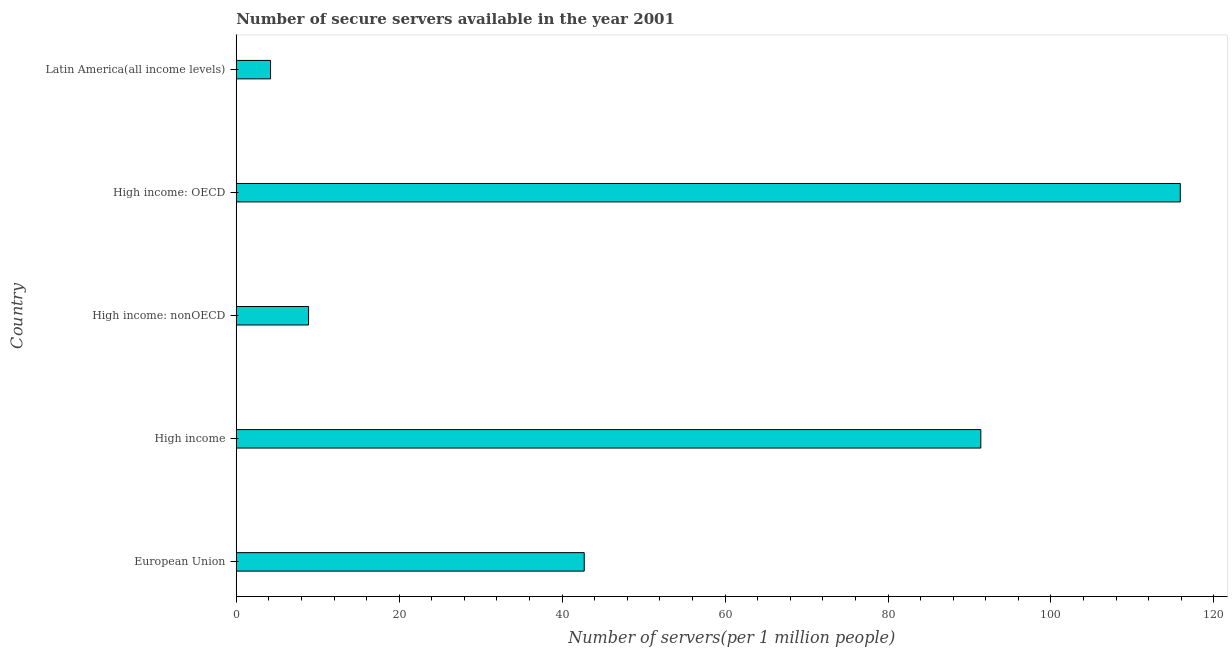What is the title of the graph?
Your answer should be very brief. Number of secure servers available in the year 2001. What is the label or title of the X-axis?
Provide a short and direct response. Number of servers(per 1 million people). What is the number of secure internet servers in High income: nonOECD?
Offer a very short reply. 8.88. Across all countries, what is the maximum number of secure internet servers?
Provide a short and direct response. 115.88. Across all countries, what is the minimum number of secure internet servers?
Offer a very short reply. 4.21. In which country was the number of secure internet servers maximum?
Ensure brevity in your answer.  High income: OECD. In which country was the number of secure internet servers minimum?
Your response must be concise. Latin America(all income levels). What is the sum of the number of secure internet servers?
Offer a terse response. 263.07. What is the difference between the number of secure internet servers in High income and High income: nonOECD?
Offer a very short reply. 82.52. What is the average number of secure internet servers per country?
Offer a terse response. 52.61. What is the median number of secure internet servers?
Your response must be concise. 42.71. In how many countries, is the number of secure internet servers greater than 92 ?
Offer a terse response. 1. What is the ratio of the number of secure internet servers in High income to that in High income: OECD?
Your answer should be very brief. 0.79. Is the number of secure internet servers in European Union less than that in Latin America(all income levels)?
Provide a succinct answer. No. What is the difference between the highest and the second highest number of secure internet servers?
Your answer should be very brief. 24.49. Is the sum of the number of secure internet servers in High income and Latin America(all income levels) greater than the maximum number of secure internet servers across all countries?
Keep it short and to the point. No. What is the difference between the highest and the lowest number of secure internet servers?
Make the answer very short. 111.67. How many bars are there?
Your answer should be compact. 5. Are all the bars in the graph horizontal?
Your response must be concise. Yes. How many countries are there in the graph?
Your answer should be compact. 5. What is the difference between two consecutive major ticks on the X-axis?
Provide a succinct answer. 20. Are the values on the major ticks of X-axis written in scientific E-notation?
Your answer should be compact. No. What is the Number of servers(per 1 million people) of European Union?
Your answer should be very brief. 42.71. What is the Number of servers(per 1 million people) of High income?
Offer a very short reply. 91.39. What is the Number of servers(per 1 million people) in High income: nonOECD?
Provide a short and direct response. 8.88. What is the Number of servers(per 1 million people) in High income: OECD?
Your response must be concise. 115.88. What is the Number of servers(per 1 million people) in Latin America(all income levels)?
Your answer should be very brief. 4.21. What is the difference between the Number of servers(per 1 million people) in European Union and High income?
Offer a terse response. -48.68. What is the difference between the Number of servers(per 1 million people) in European Union and High income: nonOECD?
Provide a succinct answer. 33.84. What is the difference between the Number of servers(per 1 million people) in European Union and High income: OECD?
Ensure brevity in your answer.  -73.16. What is the difference between the Number of servers(per 1 million people) in European Union and Latin America(all income levels)?
Your answer should be compact. 38.51. What is the difference between the Number of servers(per 1 million people) in High income and High income: nonOECD?
Provide a succinct answer. 82.52. What is the difference between the Number of servers(per 1 million people) in High income and High income: OECD?
Your response must be concise. -24.49. What is the difference between the Number of servers(per 1 million people) in High income and Latin America(all income levels)?
Keep it short and to the point. 87.18. What is the difference between the Number of servers(per 1 million people) in High income: nonOECD and High income: OECD?
Offer a terse response. -107. What is the difference between the Number of servers(per 1 million people) in High income: nonOECD and Latin America(all income levels)?
Give a very brief answer. 4.67. What is the difference between the Number of servers(per 1 million people) in High income: OECD and Latin America(all income levels)?
Keep it short and to the point. 111.67. What is the ratio of the Number of servers(per 1 million people) in European Union to that in High income?
Keep it short and to the point. 0.47. What is the ratio of the Number of servers(per 1 million people) in European Union to that in High income: nonOECD?
Your response must be concise. 4.81. What is the ratio of the Number of servers(per 1 million people) in European Union to that in High income: OECD?
Your response must be concise. 0.37. What is the ratio of the Number of servers(per 1 million people) in European Union to that in Latin America(all income levels)?
Your response must be concise. 10.15. What is the ratio of the Number of servers(per 1 million people) in High income to that in High income: nonOECD?
Offer a terse response. 10.3. What is the ratio of the Number of servers(per 1 million people) in High income to that in High income: OECD?
Your answer should be very brief. 0.79. What is the ratio of the Number of servers(per 1 million people) in High income to that in Latin America(all income levels)?
Your response must be concise. 21.72. What is the ratio of the Number of servers(per 1 million people) in High income: nonOECD to that in High income: OECD?
Offer a terse response. 0.08. What is the ratio of the Number of servers(per 1 million people) in High income: nonOECD to that in Latin America(all income levels)?
Provide a succinct answer. 2.11. What is the ratio of the Number of servers(per 1 million people) in High income: OECD to that in Latin America(all income levels)?
Your response must be concise. 27.53. 